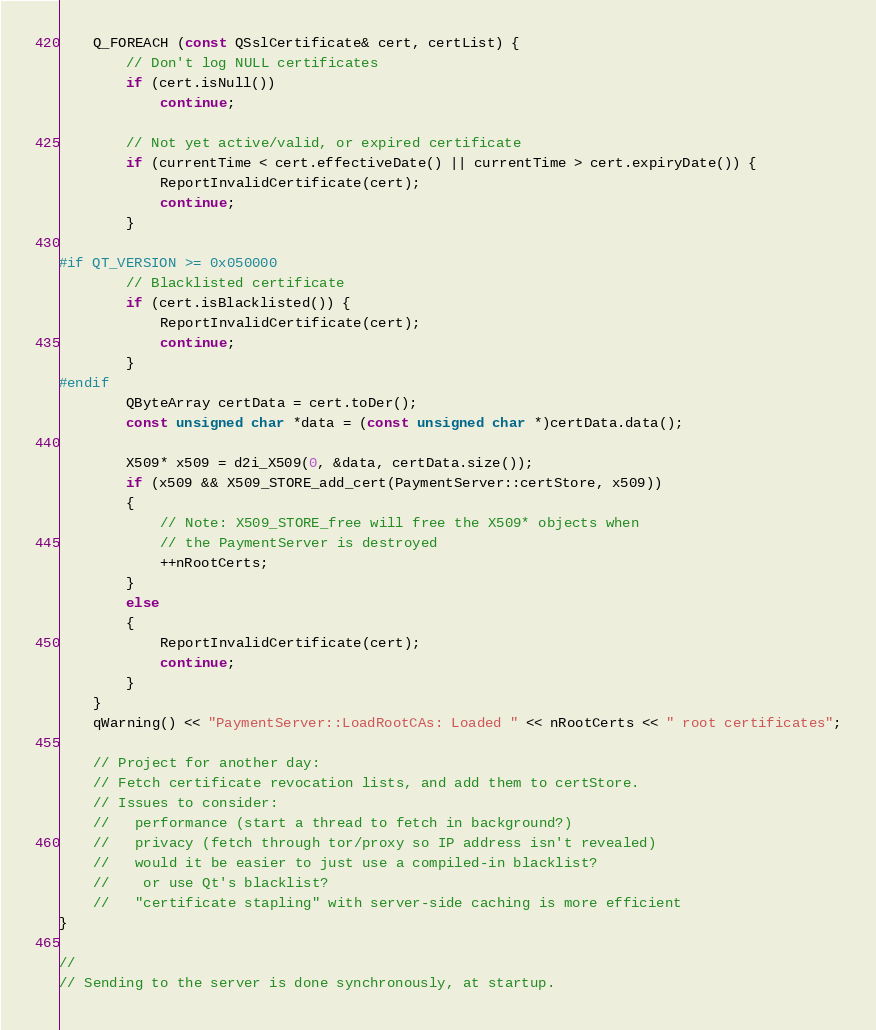<code> <loc_0><loc_0><loc_500><loc_500><_C++_>
    Q_FOREACH (const QSslCertificate& cert, certList) {
        // Don't log NULL certificates
        if (cert.isNull())
            continue;

        // Not yet active/valid, or expired certificate
        if (currentTime < cert.effectiveDate() || currentTime > cert.expiryDate()) {
            ReportInvalidCertificate(cert);
            continue;
        }

#if QT_VERSION >= 0x050000
        // Blacklisted certificate
        if (cert.isBlacklisted()) {
            ReportInvalidCertificate(cert);
            continue;
        }
#endif
        QByteArray certData = cert.toDer();
        const unsigned char *data = (const unsigned char *)certData.data();

        X509* x509 = d2i_X509(0, &data, certData.size());
        if (x509 && X509_STORE_add_cert(PaymentServer::certStore, x509))
        {
            // Note: X509_STORE_free will free the X509* objects when
            // the PaymentServer is destroyed
            ++nRootCerts;
        }
        else
        {
            ReportInvalidCertificate(cert);
            continue;
        }
    }
    qWarning() << "PaymentServer::LoadRootCAs: Loaded " << nRootCerts << " root certificates";

    // Project for another day:
    // Fetch certificate revocation lists, and add them to certStore.
    // Issues to consider:
    //   performance (start a thread to fetch in background?)
    //   privacy (fetch through tor/proxy so IP address isn't revealed)
    //   would it be easier to just use a compiled-in blacklist?
    //    or use Qt's blacklist?
    //   "certificate stapling" with server-side caching is more efficient
}

//
// Sending to the server is done synchronously, at startup.</code> 